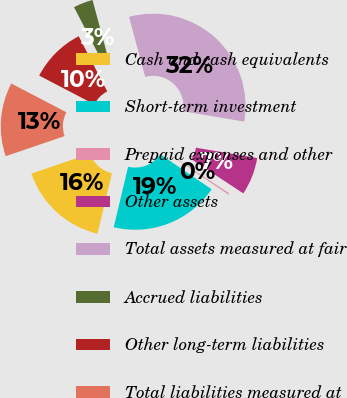<chart> <loc_0><loc_0><loc_500><loc_500><pie_chart><fcel>Cash and cash equivalents<fcel>Short-term investment<fcel>Prepaid expenses and other<fcel>Other assets<fcel>Total assets measured at fair<fcel>Accrued liabilities<fcel>Other long-term liabilities<fcel>Total liabilities measured at<nl><fcel>16.05%<fcel>19.21%<fcel>0.26%<fcel>6.58%<fcel>31.85%<fcel>3.42%<fcel>9.74%<fcel>12.89%<nl></chart> 